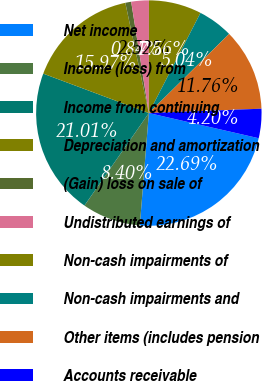<chart> <loc_0><loc_0><loc_500><loc_500><pie_chart><fcel>Net income<fcel>Income (loss) from<fcel>Income from continuing<fcel>Depreciation and amortization<fcel>(Gain) loss on sale of<fcel>Undistributed earnings of<fcel>Non-cash impairments of<fcel>Non-cash impairments and<fcel>Other items (includes pension<fcel>Accounts receivable<nl><fcel>22.68%<fcel>8.4%<fcel>21.0%<fcel>15.96%<fcel>0.84%<fcel>2.52%<fcel>7.56%<fcel>5.04%<fcel>11.76%<fcel>4.2%<nl></chart> 